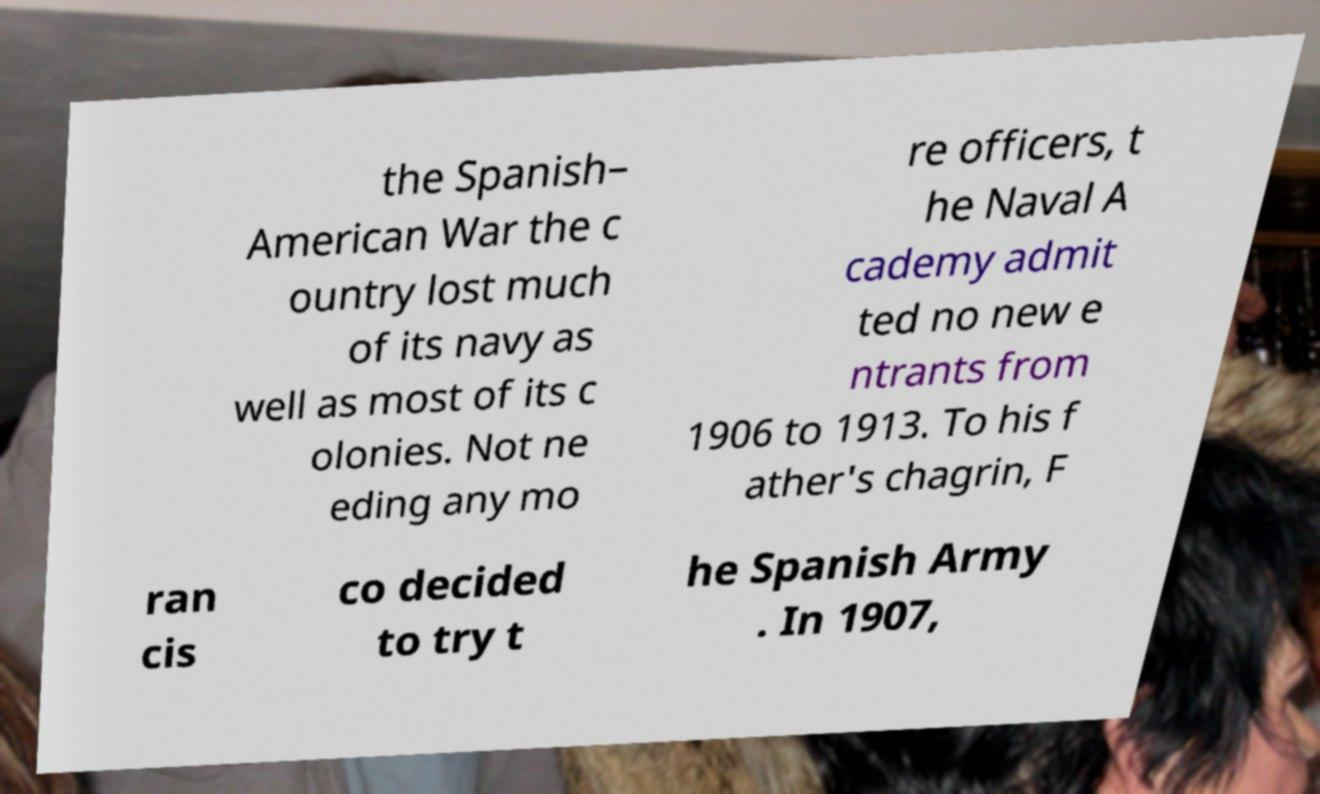Could you extract and type out the text from this image? the Spanish– American War the c ountry lost much of its navy as well as most of its c olonies. Not ne eding any mo re officers, t he Naval A cademy admit ted no new e ntrants from 1906 to 1913. To his f ather's chagrin, F ran cis co decided to try t he Spanish Army . In 1907, 